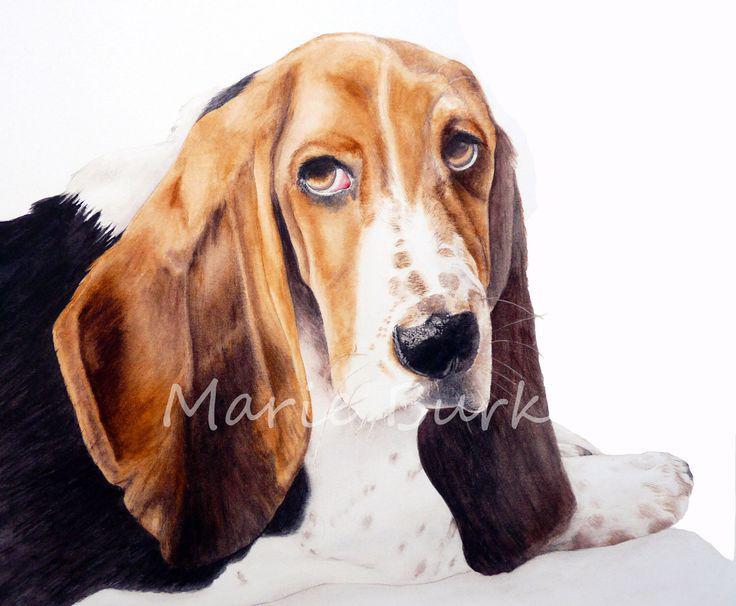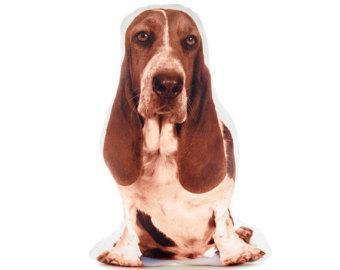The first image is the image on the left, the second image is the image on the right. Given the left and right images, does the statement "There are at least two dogs in the image on the right." hold true? Answer yes or no. No. 